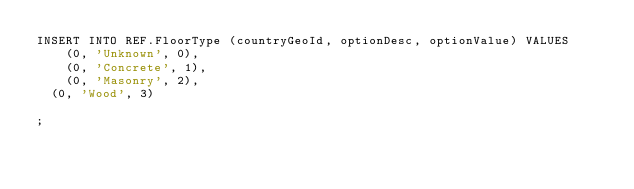Convert code to text. <code><loc_0><loc_0><loc_500><loc_500><_SQL_>INSERT INTO REF.FloorType (countryGeoId, optionDesc, optionValue) VALUES
    (0, 'Unknown', 0),
    (0, 'Concrete', 1),
    (0, 'Masonry', 2),
	(0, 'Wood', 3)
  
;</code> 